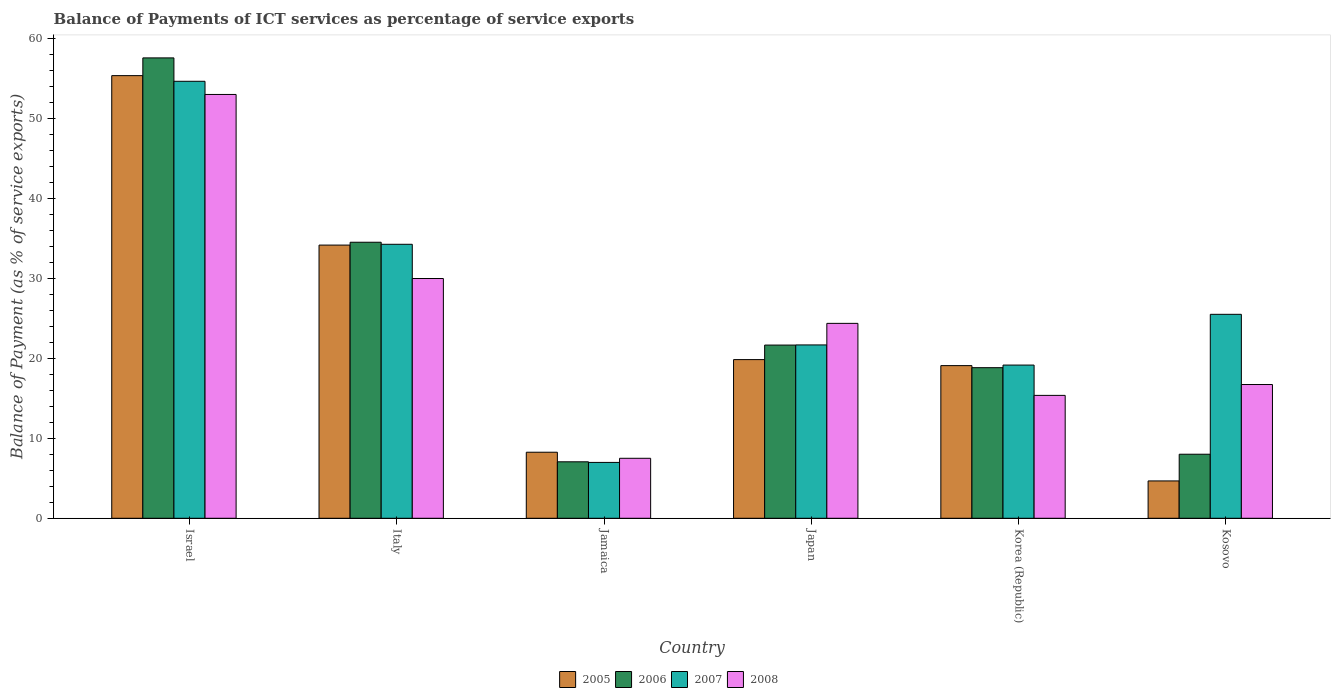How many different coloured bars are there?
Your response must be concise. 4. Are the number of bars on each tick of the X-axis equal?
Your response must be concise. Yes. How many bars are there on the 6th tick from the left?
Make the answer very short. 4. How many bars are there on the 3rd tick from the right?
Your response must be concise. 4. What is the label of the 1st group of bars from the left?
Ensure brevity in your answer.  Israel. In how many cases, is the number of bars for a given country not equal to the number of legend labels?
Ensure brevity in your answer.  0. What is the balance of payments of ICT services in 2008 in Jamaica?
Your answer should be very brief. 7.5. Across all countries, what is the maximum balance of payments of ICT services in 2006?
Make the answer very short. 57.59. Across all countries, what is the minimum balance of payments of ICT services in 2007?
Your answer should be compact. 6.99. In which country was the balance of payments of ICT services in 2007 minimum?
Provide a succinct answer. Jamaica. What is the total balance of payments of ICT services in 2006 in the graph?
Keep it short and to the point. 147.7. What is the difference between the balance of payments of ICT services in 2007 in Israel and that in Italy?
Provide a short and direct response. 20.39. What is the difference between the balance of payments of ICT services in 2006 in Japan and the balance of payments of ICT services in 2007 in Italy?
Ensure brevity in your answer.  -12.61. What is the average balance of payments of ICT services in 2006 per country?
Provide a succinct answer. 24.62. What is the difference between the balance of payments of ICT services of/in 2006 and balance of payments of ICT services of/in 2005 in Israel?
Provide a succinct answer. 2.22. What is the ratio of the balance of payments of ICT services in 2008 in Italy to that in Kosovo?
Ensure brevity in your answer.  1.79. Is the balance of payments of ICT services in 2006 in Italy less than that in Korea (Republic)?
Make the answer very short. No. Is the difference between the balance of payments of ICT services in 2006 in Israel and Korea (Republic) greater than the difference between the balance of payments of ICT services in 2005 in Israel and Korea (Republic)?
Your response must be concise. Yes. What is the difference between the highest and the second highest balance of payments of ICT services in 2006?
Offer a terse response. 23.06. What is the difference between the highest and the lowest balance of payments of ICT services in 2006?
Make the answer very short. 50.53. Is the sum of the balance of payments of ICT services in 2007 in Italy and Jamaica greater than the maximum balance of payments of ICT services in 2006 across all countries?
Ensure brevity in your answer.  No. What does the 4th bar from the left in Israel represents?
Provide a short and direct response. 2008. What does the 3rd bar from the right in Jamaica represents?
Keep it short and to the point. 2006. Is it the case that in every country, the sum of the balance of payments of ICT services in 2008 and balance of payments of ICT services in 2006 is greater than the balance of payments of ICT services in 2005?
Give a very brief answer. Yes. Are all the bars in the graph horizontal?
Make the answer very short. No. Are the values on the major ticks of Y-axis written in scientific E-notation?
Provide a succinct answer. No. Does the graph contain any zero values?
Keep it short and to the point. No. Where does the legend appear in the graph?
Offer a very short reply. Bottom center. How are the legend labels stacked?
Offer a terse response. Horizontal. What is the title of the graph?
Offer a terse response. Balance of Payments of ICT services as percentage of service exports. Does "2009" appear as one of the legend labels in the graph?
Ensure brevity in your answer.  No. What is the label or title of the Y-axis?
Your response must be concise. Balance of Payment (as % of service exports). What is the Balance of Payment (as % of service exports) of 2005 in Israel?
Offer a terse response. 55.37. What is the Balance of Payment (as % of service exports) of 2006 in Israel?
Provide a succinct answer. 57.59. What is the Balance of Payment (as % of service exports) of 2007 in Israel?
Your answer should be compact. 54.67. What is the Balance of Payment (as % of service exports) of 2008 in Israel?
Provide a short and direct response. 53.02. What is the Balance of Payment (as % of service exports) of 2005 in Italy?
Provide a succinct answer. 34.17. What is the Balance of Payment (as % of service exports) of 2006 in Italy?
Provide a short and direct response. 34.53. What is the Balance of Payment (as % of service exports) in 2007 in Italy?
Your answer should be very brief. 34.28. What is the Balance of Payment (as % of service exports) of 2008 in Italy?
Your answer should be compact. 29.99. What is the Balance of Payment (as % of service exports) in 2005 in Jamaica?
Your answer should be very brief. 8.26. What is the Balance of Payment (as % of service exports) in 2006 in Jamaica?
Offer a very short reply. 7.06. What is the Balance of Payment (as % of service exports) of 2007 in Jamaica?
Give a very brief answer. 6.99. What is the Balance of Payment (as % of service exports) in 2008 in Jamaica?
Keep it short and to the point. 7.5. What is the Balance of Payment (as % of service exports) of 2005 in Japan?
Your response must be concise. 19.85. What is the Balance of Payment (as % of service exports) in 2006 in Japan?
Keep it short and to the point. 21.67. What is the Balance of Payment (as % of service exports) of 2007 in Japan?
Offer a very short reply. 21.69. What is the Balance of Payment (as % of service exports) of 2008 in Japan?
Your response must be concise. 24.38. What is the Balance of Payment (as % of service exports) in 2005 in Korea (Republic)?
Your answer should be compact. 19.1. What is the Balance of Payment (as % of service exports) in 2006 in Korea (Republic)?
Make the answer very short. 18.84. What is the Balance of Payment (as % of service exports) of 2007 in Korea (Republic)?
Give a very brief answer. 19.16. What is the Balance of Payment (as % of service exports) in 2008 in Korea (Republic)?
Ensure brevity in your answer.  15.37. What is the Balance of Payment (as % of service exports) in 2005 in Kosovo?
Offer a very short reply. 4.67. What is the Balance of Payment (as % of service exports) in 2006 in Kosovo?
Provide a short and direct response. 8.01. What is the Balance of Payment (as % of service exports) in 2007 in Kosovo?
Your answer should be compact. 25.51. What is the Balance of Payment (as % of service exports) in 2008 in Kosovo?
Make the answer very short. 16.73. Across all countries, what is the maximum Balance of Payment (as % of service exports) of 2005?
Ensure brevity in your answer.  55.37. Across all countries, what is the maximum Balance of Payment (as % of service exports) of 2006?
Give a very brief answer. 57.59. Across all countries, what is the maximum Balance of Payment (as % of service exports) in 2007?
Provide a short and direct response. 54.67. Across all countries, what is the maximum Balance of Payment (as % of service exports) of 2008?
Ensure brevity in your answer.  53.02. Across all countries, what is the minimum Balance of Payment (as % of service exports) in 2005?
Ensure brevity in your answer.  4.67. Across all countries, what is the minimum Balance of Payment (as % of service exports) of 2006?
Your answer should be very brief. 7.06. Across all countries, what is the minimum Balance of Payment (as % of service exports) in 2007?
Offer a very short reply. 6.99. Across all countries, what is the minimum Balance of Payment (as % of service exports) of 2008?
Your answer should be very brief. 7.5. What is the total Balance of Payment (as % of service exports) of 2005 in the graph?
Your response must be concise. 141.43. What is the total Balance of Payment (as % of service exports) in 2006 in the graph?
Offer a very short reply. 147.7. What is the total Balance of Payment (as % of service exports) of 2007 in the graph?
Keep it short and to the point. 162.29. What is the total Balance of Payment (as % of service exports) of 2008 in the graph?
Offer a very short reply. 147. What is the difference between the Balance of Payment (as % of service exports) in 2005 in Israel and that in Italy?
Give a very brief answer. 21.2. What is the difference between the Balance of Payment (as % of service exports) of 2006 in Israel and that in Italy?
Make the answer very short. 23.06. What is the difference between the Balance of Payment (as % of service exports) of 2007 in Israel and that in Italy?
Keep it short and to the point. 20.39. What is the difference between the Balance of Payment (as % of service exports) in 2008 in Israel and that in Italy?
Keep it short and to the point. 23.02. What is the difference between the Balance of Payment (as % of service exports) of 2005 in Israel and that in Jamaica?
Offer a terse response. 47.11. What is the difference between the Balance of Payment (as % of service exports) of 2006 in Israel and that in Jamaica?
Offer a very short reply. 50.53. What is the difference between the Balance of Payment (as % of service exports) in 2007 in Israel and that in Jamaica?
Your answer should be very brief. 47.68. What is the difference between the Balance of Payment (as % of service exports) in 2008 in Israel and that in Jamaica?
Your answer should be very brief. 45.51. What is the difference between the Balance of Payment (as % of service exports) of 2005 in Israel and that in Japan?
Your answer should be compact. 35.52. What is the difference between the Balance of Payment (as % of service exports) in 2006 in Israel and that in Japan?
Your answer should be very brief. 35.93. What is the difference between the Balance of Payment (as % of service exports) of 2007 in Israel and that in Japan?
Give a very brief answer. 32.98. What is the difference between the Balance of Payment (as % of service exports) of 2008 in Israel and that in Japan?
Offer a terse response. 28.64. What is the difference between the Balance of Payment (as % of service exports) of 2005 in Israel and that in Korea (Republic)?
Your answer should be very brief. 36.28. What is the difference between the Balance of Payment (as % of service exports) of 2006 in Israel and that in Korea (Republic)?
Your response must be concise. 38.75. What is the difference between the Balance of Payment (as % of service exports) in 2007 in Israel and that in Korea (Republic)?
Ensure brevity in your answer.  35.5. What is the difference between the Balance of Payment (as % of service exports) of 2008 in Israel and that in Korea (Republic)?
Your answer should be compact. 37.64. What is the difference between the Balance of Payment (as % of service exports) in 2005 in Israel and that in Kosovo?
Offer a terse response. 50.7. What is the difference between the Balance of Payment (as % of service exports) of 2006 in Israel and that in Kosovo?
Make the answer very short. 49.58. What is the difference between the Balance of Payment (as % of service exports) in 2007 in Israel and that in Kosovo?
Provide a short and direct response. 29.15. What is the difference between the Balance of Payment (as % of service exports) of 2008 in Israel and that in Kosovo?
Offer a terse response. 36.29. What is the difference between the Balance of Payment (as % of service exports) in 2005 in Italy and that in Jamaica?
Offer a very short reply. 25.91. What is the difference between the Balance of Payment (as % of service exports) in 2006 in Italy and that in Jamaica?
Ensure brevity in your answer.  27.47. What is the difference between the Balance of Payment (as % of service exports) in 2007 in Italy and that in Jamaica?
Your response must be concise. 27.29. What is the difference between the Balance of Payment (as % of service exports) of 2008 in Italy and that in Jamaica?
Keep it short and to the point. 22.49. What is the difference between the Balance of Payment (as % of service exports) in 2005 in Italy and that in Japan?
Provide a short and direct response. 14.33. What is the difference between the Balance of Payment (as % of service exports) of 2006 in Italy and that in Japan?
Give a very brief answer. 12.87. What is the difference between the Balance of Payment (as % of service exports) of 2007 in Italy and that in Japan?
Make the answer very short. 12.59. What is the difference between the Balance of Payment (as % of service exports) in 2008 in Italy and that in Japan?
Offer a terse response. 5.61. What is the difference between the Balance of Payment (as % of service exports) in 2005 in Italy and that in Korea (Republic)?
Make the answer very short. 15.08. What is the difference between the Balance of Payment (as % of service exports) of 2006 in Italy and that in Korea (Republic)?
Your answer should be very brief. 15.69. What is the difference between the Balance of Payment (as % of service exports) of 2007 in Italy and that in Korea (Republic)?
Your answer should be compact. 15.11. What is the difference between the Balance of Payment (as % of service exports) in 2008 in Italy and that in Korea (Republic)?
Offer a terse response. 14.62. What is the difference between the Balance of Payment (as % of service exports) of 2005 in Italy and that in Kosovo?
Give a very brief answer. 29.5. What is the difference between the Balance of Payment (as % of service exports) of 2006 in Italy and that in Kosovo?
Your answer should be compact. 26.52. What is the difference between the Balance of Payment (as % of service exports) of 2007 in Italy and that in Kosovo?
Keep it short and to the point. 8.76. What is the difference between the Balance of Payment (as % of service exports) of 2008 in Italy and that in Kosovo?
Give a very brief answer. 13.26. What is the difference between the Balance of Payment (as % of service exports) in 2005 in Jamaica and that in Japan?
Provide a succinct answer. -11.59. What is the difference between the Balance of Payment (as % of service exports) of 2006 in Jamaica and that in Japan?
Your answer should be compact. -14.6. What is the difference between the Balance of Payment (as % of service exports) in 2007 in Jamaica and that in Japan?
Keep it short and to the point. -14.7. What is the difference between the Balance of Payment (as % of service exports) of 2008 in Jamaica and that in Japan?
Offer a very short reply. -16.88. What is the difference between the Balance of Payment (as % of service exports) in 2005 in Jamaica and that in Korea (Republic)?
Your response must be concise. -10.83. What is the difference between the Balance of Payment (as % of service exports) in 2006 in Jamaica and that in Korea (Republic)?
Keep it short and to the point. -11.78. What is the difference between the Balance of Payment (as % of service exports) in 2007 in Jamaica and that in Korea (Republic)?
Provide a succinct answer. -12.18. What is the difference between the Balance of Payment (as % of service exports) in 2008 in Jamaica and that in Korea (Republic)?
Give a very brief answer. -7.87. What is the difference between the Balance of Payment (as % of service exports) of 2005 in Jamaica and that in Kosovo?
Provide a short and direct response. 3.59. What is the difference between the Balance of Payment (as % of service exports) in 2006 in Jamaica and that in Kosovo?
Your answer should be very brief. -0.95. What is the difference between the Balance of Payment (as % of service exports) of 2007 in Jamaica and that in Kosovo?
Give a very brief answer. -18.53. What is the difference between the Balance of Payment (as % of service exports) in 2008 in Jamaica and that in Kosovo?
Ensure brevity in your answer.  -9.23. What is the difference between the Balance of Payment (as % of service exports) of 2005 in Japan and that in Korea (Republic)?
Offer a terse response. 0.75. What is the difference between the Balance of Payment (as % of service exports) in 2006 in Japan and that in Korea (Republic)?
Ensure brevity in your answer.  2.83. What is the difference between the Balance of Payment (as % of service exports) of 2007 in Japan and that in Korea (Republic)?
Ensure brevity in your answer.  2.52. What is the difference between the Balance of Payment (as % of service exports) in 2008 in Japan and that in Korea (Republic)?
Make the answer very short. 9.01. What is the difference between the Balance of Payment (as % of service exports) of 2005 in Japan and that in Kosovo?
Offer a terse response. 15.18. What is the difference between the Balance of Payment (as % of service exports) in 2006 in Japan and that in Kosovo?
Provide a short and direct response. 13.66. What is the difference between the Balance of Payment (as % of service exports) in 2007 in Japan and that in Kosovo?
Provide a short and direct response. -3.83. What is the difference between the Balance of Payment (as % of service exports) in 2008 in Japan and that in Kosovo?
Offer a terse response. 7.65. What is the difference between the Balance of Payment (as % of service exports) of 2005 in Korea (Republic) and that in Kosovo?
Ensure brevity in your answer.  14.43. What is the difference between the Balance of Payment (as % of service exports) of 2006 in Korea (Republic) and that in Kosovo?
Your answer should be compact. 10.83. What is the difference between the Balance of Payment (as % of service exports) of 2007 in Korea (Republic) and that in Kosovo?
Offer a terse response. -6.35. What is the difference between the Balance of Payment (as % of service exports) in 2008 in Korea (Republic) and that in Kosovo?
Keep it short and to the point. -1.36. What is the difference between the Balance of Payment (as % of service exports) in 2005 in Israel and the Balance of Payment (as % of service exports) in 2006 in Italy?
Provide a succinct answer. 20.84. What is the difference between the Balance of Payment (as % of service exports) in 2005 in Israel and the Balance of Payment (as % of service exports) in 2007 in Italy?
Your answer should be compact. 21.1. What is the difference between the Balance of Payment (as % of service exports) of 2005 in Israel and the Balance of Payment (as % of service exports) of 2008 in Italy?
Offer a very short reply. 25.38. What is the difference between the Balance of Payment (as % of service exports) of 2006 in Israel and the Balance of Payment (as % of service exports) of 2007 in Italy?
Provide a short and direct response. 23.32. What is the difference between the Balance of Payment (as % of service exports) in 2006 in Israel and the Balance of Payment (as % of service exports) in 2008 in Italy?
Your answer should be very brief. 27.6. What is the difference between the Balance of Payment (as % of service exports) in 2007 in Israel and the Balance of Payment (as % of service exports) in 2008 in Italy?
Provide a short and direct response. 24.67. What is the difference between the Balance of Payment (as % of service exports) in 2005 in Israel and the Balance of Payment (as % of service exports) in 2006 in Jamaica?
Provide a short and direct response. 48.31. What is the difference between the Balance of Payment (as % of service exports) of 2005 in Israel and the Balance of Payment (as % of service exports) of 2007 in Jamaica?
Offer a terse response. 48.39. What is the difference between the Balance of Payment (as % of service exports) of 2005 in Israel and the Balance of Payment (as % of service exports) of 2008 in Jamaica?
Ensure brevity in your answer.  47.87. What is the difference between the Balance of Payment (as % of service exports) of 2006 in Israel and the Balance of Payment (as % of service exports) of 2007 in Jamaica?
Keep it short and to the point. 50.61. What is the difference between the Balance of Payment (as % of service exports) in 2006 in Israel and the Balance of Payment (as % of service exports) in 2008 in Jamaica?
Keep it short and to the point. 50.09. What is the difference between the Balance of Payment (as % of service exports) in 2007 in Israel and the Balance of Payment (as % of service exports) in 2008 in Jamaica?
Your answer should be very brief. 47.16. What is the difference between the Balance of Payment (as % of service exports) in 2005 in Israel and the Balance of Payment (as % of service exports) in 2006 in Japan?
Give a very brief answer. 33.71. What is the difference between the Balance of Payment (as % of service exports) in 2005 in Israel and the Balance of Payment (as % of service exports) in 2007 in Japan?
Provide a short and direct response. 33.69. What is the difference between the Balance of Payment (as % of service exports) of 2005 in Israel and the Balance of Payment (as % of service exports) of 2008 in Japan?
Make the answer very short. 30.99. What is the difference between the Balance of Payment (as % of service exports) of 2006 in Israel and the Balance of Payment (as % of service exports) of 2007 in Japan?
Offer a very short reply. 35.91. What is the difference between the Balance of Payment (as % of service exports) of 2006 in Israel and the Balance of Payment (as % of service exports) of 2008 in Japan?
Keep it short and to the point. 33.21. What is the difference between the Balance of Payment (as % of service exports) of 2007 in Israel and the Balance of Payment (as % of service exports) of 2008 in Japan?
Keep it short and to the point. 30.28. What is the difference between the Balance of Payment (as % of service exports) of 2005 in Israel and the Balance of Payment (as % of service exports) of 2006 in Korea (Republic)?
Ensure brevity in your answer.  36.53. What is the difference between the Balance of Payment (as % of service exports) of 2005 in Israel and the Balance of Payment (as % of service exports) of 2007 in Korea (Republic)?
Provide a short and direct response. 36.21. What is the difference between the Balance of Payment (as % of service exports) in 2005 in Israel and the Balance of Payment (as % of service exports) in 2008 in Korea (Republic)?
Give a very brief answer. 40. What is the difference between the Balance of Payment (as % of service exports) in 2006 in Israel and the Balance of Payment (as % of service exports) in 2007 in Korea (Republic)?
Ensure brevity in your answer.  38.43. What is the difference between the Balance of Payment (as % of service exports) in 2006 in Israel and the Balance of Payment (as % of service exports) in 2008 in Korea (Republic)?
Keep it short and to the point. 42.22. What is the difference between the Balance of Payment (as % of service exports) of 2007 in Israel and the Balance of Payment (as % of service exports) of 2008 in Korea (Republic)?
Provide a succinct answer. 39.29. What is the difference between the Balance of Payment (as % of service exports) in 2005 in Israel and the Balance of Payment (as % of service exports) in 2006 in Kosovo?
Your response must be concise. 47.36. What is the difference between the Balance of Payment (as % of service exports) of 2005 in Israel and the Balance of Payment (as % of service exports) of 2007 in Kosovo?
Your response must be concise. 29.86. What is the difference between the Balance of Payment (as % of service exports) of 2005 in Israel and the Balance of Payment (as % of service exports) of 2008 in Kosovo?
Make the answer very short. 38.64. What is the difference between the Balance of Payment (as % of service exports) in 2006 in Israel and the Balance of Payment (as % of service exports) in 2007 in Kosovo?
Your answer should be compact. 32.08. What is the difference between the Balance of Payment (as % of service exports) of 2006 in Israel and the Balance of Payment (as % of service exports) of 2008 in Kosovo?
Keep it short and to the point. 40.86. What is the difference between the Balance of Payment (as % of service exports) of 2007 in Israel and the Balance of Payment (as % of service exports) of 2008 in Kosovo?
Offer a very short reply. 37.94. What is the difference between the Balance of Payment (as % of service exports) in 2005 in Italy and the Balance of Payment (as % of service exports) in 2006 in Jamaica?
Your answer should be compact. 27.11. What is the difference between the Balance of Payment (as % of service exports) of 2005 in Italy and the Balance of Payment (as % of service exports) of 2007 in Jamaica?
Provide a short and direct response. 27.19. What is the difference between the Balance of Payment (as % of service exports) in 2005 in Italy and the Balance of Payment (as % of service exports) in 2008 in Jamaica?
Offer a terse response. 26.67. What is the difference between the Balance of Payment (as % of service exports) of 2006 in Italy and the Balance of Payment (as % of service exports) of 2007 in Jamaica?
Ensure brevity in your answer.  27.54. What is the difference between the Balance of Payment (as % of service exports) of 2006 in Italy and the Balance of Payment (as % of service exports) of 2008 in Jamaica?
Ensure brevity in your answer.  27.03. What is the difference between the Balance of Payment (as % of service exports) of 2007 in Italy and the Balance of Payment (as % of service exports) of 2008 in Jamaica?
Give a very brief answer. 26.77. What is the difference between the Balance of Payment (as % of service exports) of 2005 in Italy and the Balance of Payment (as % of service exports) of 2006 in Japan?
Ensure brevity in your answer.  12.51. What is the difference between the Balance of Payment (as % of service exports) in 2005 in Italy and the Balance of Payment (as % of service exports) in 2007 in Japan?
Your answer should be very brief. 12.49. What is the difference between the Balance of Payment (as % of service exports) of 2005 in Italy and the Balance of Payment (as % of service exports) of 2008 in Japan?
Your answer should be very brief. 9.79. What is the difference between the Balance of Payment (as % of service exports) of 2006 in Italy and the Balance of Payment (as % of service exports) of 2007 in Japan?
Offer a terse response. 12.85. What is the difference between the Balance of Payment (as % of service exports) of 2006 in Italy and the Balance of Payment (as % of service exports) of 2008 in Japan?
Give a very brief answer. 10.15. What is the difference between the Balance of Payment (as % of service exports) of 2007 in Italy and the Balance of Payment (as % of service exports) of 2008 in Japan?
Provide a short and direct response. 9.89. What is the difference between the Balance of Payment (as % of service exports) in 2005 in Italy and the Balance of Payment (as % of service exports) in 2006 in Korea (Republic)?
Give a very brief answer. 15.34. What is the difference between the Balance of Payment (as % of service exports) of 2005 in Italy and the Balance of Payment (as % of service exports) of 2007 in Korea (Republic)?
Ensure brevity in your answer.  15.01. What is the difference between the Balance of Payment (as % of service exports) in 2005 in Italy and the Balance of Payment (as % of service exports) in 2008 in Korea (Republic)?
Your response must be concise. 18.8. What is the difference between the Balance of Payment (as % of service exports) in 2006 in Italy and the Balance of Payment (as % of service exports) in 2007 in Korea (Republic)?
Provide a succinct answer. 15.37. What is the difference between the Balance of Payment (as % of service exports) of 2006 in Italy and the Balance of Payment (as % of service exports) of 2008 in Korea (Republic)?
Make the answer very short. 19.16. What is the difference between the Balance of Payment (as % of service exports) in 2007 in Italy and the Balance of Payment (as % of service exports) in 2008 in Korea (Republic)?
Ensure brevity in your answer.  18.9. What is the difference between the Balance of Payment (as % of service exports) of 2005 in Italy and the Balance of Payment (as % of service exports) of 2006 in Kosovo?
Your answer should be very brief. 26.16. What is the difference between the Balance of Payment (as % of service exports) of 2005 in Italy and the Balance of Payment (as % of service exports) of 2007 in Kosovo?
Make the answer very short. 8.66. What is the difference between the Balance of Payment (as % of service exports) of 2005 in Italy and the Balance of Payment (as % of service exports) of 2008 in Kosovo?
Offer a terse response. 17.44. What is the difference between the Balance of Payment (as % of service exports) in 2006 in Italy and the Balance of Payment (as % of service exports) in 2007 in Kosovo?
Make the answer very short. 9.02. What is the difference between the Balance of Payment (as % of service exports) of 2006 in Italy and the Balance of Payment (as % of service exports) of 2008 in Kosovo?
Your answer should be very brief. 17.8. What is the difference between the Balance of Payment (as % of service exports) of 2007 in Italy and the Balance of Payment (as % of service exports) of 2008 in Kosovo?
Provide a short and direct response. 17.54. What is the difference between the Balance of Payment (as % of service exports) of 2005 in Jamaica and the Balance of Payment (as % of service exports) of 2006 in Japan?
Provide a short and direct response. -13.4. What is the difference between the Balance of Payment (as % of service exports) in 2005 in Jamaica and the Balance of Payment (as % of service exports) in 2007 in Japan?
Ensure brevity in your answer.  -13.42. What is the difference between the Balance of Payment (as % of service exports) in 2005 in Jamaica and the Balance of Payment (as % of service exports) in 2008 in Japan?
Your answer should be very brief. -16.12. What is the difference between the Balance of Payment (as % of service exports) of 2006 in Jamaica and the Balance of Payment (as % of service exports) of 2007 in Japan?
Your response must be concise. -14.62. What is the difference between the Balance of Payment (as % of service exports) of 2006 in Jamaica and the Balance of Payment (as % of service exports) of 2008 in Japan?
Offer a terse response. -17.32. What is the difference between the Balance of Payment (as % of service exports) of 2007 in Jamaica and the Balance of Payment (as % of service exports) of 2008 in Japan?
Give a very brief answer. -17.39. What is the difference between the Balance of Payment (as % of service exports) of 2005 in Jamaica and the Balance of Payment (as % of service exports) of 2006 in Korea (Republic)?
Your answer should be very brief. -10.58. What is the difference between the Balance of Payment (as % of service exports) of 2005 in Jamaica and the Balance of Payment (as % of service exports) of 2007 in Korea (Republic)?
Provide a short and direct response. -10.9. What is the difference between the Balance of Payment (as % of service exports) of 2005 in Jamaica and the Balance of Payment (as % of service exports) of 2008 in Korea (Republic)?
Offer a very short reply. -7.11. What is the difference between the Balance of Payment (as % of service exports) of 2006 in Jamaica and the Balance of Payment (as % of service exports) of 2007 in Korea (Republic)?
Your answer should be compact. -12.1. What is the difference between the Balance of Payment (as % of service exports) in 2006 in Jamaica and the Balance of Payment (as % of service exports) in 2008 in Korea (Republic)?
Your response must be concise. -8.31. What is the difference between the Balance of Payment (as % of service exports) in 2007 in Jamaica and the Balance of Payment (as % of service exports) in 2008 in Korea (Republic)?
Make the answer very short. -8.39. What is the difference between the Balance of Payment (as % of service exports) of 2005 in Jamaica and the Balance of Payment (as % of service exports) of 2006 in Kosovo?
Offer a very short reply. 0.25. What is the difference between the Balance of Payment (as % of service exports) in 2005 in Jamaica and the Balance of Payment (as % of service exports) in 2007 in Kosovo?
Provide a succinct answer. -17.25. What is the difference between the Balance of Payment (as % of service exports) in 2005 in Jamaica and the Balance of Payment (as % of service exports) in 2008 in Kosovo?
Give a very brief answer. -8.47. What is the difference between the Balance of Payment (as % of service exports) of 2006 in Jamaica and the Balance of Payment (as % of service exports) of 2007 in Kosovo?
Your response must be concise. -18.45. What is the difference between the Balance of Payment (as % of service exports) of 2006 in Jamaica and the Balance of Payment (as % of service exports) of 2008 in Kosovo?
Offer a very short reply. -9.67. What is the difference between the Balance of Payment (as % of service exports) in 2007 in Jamaica and the Balance of Payment (as % of service exports) in 2008 in Kosovo?
Offer a very short reply. -9.74. What is the difference between the Balance of Payment (as % of service exports) in 2005 in Japan and the Balance of Payment (as % of service exports) in 2006 in Korea (Republic)?
Your response must be concise. 1.01. What is the difference between the Balance of Payment (as % of service exports) in 2005 in Japan and the Balance of Payment (as % of service exports) in 2007 in Korea (Republic)?
Keep it short and to the point. 0.68. What is the difference between the Balance of Payment (as % of service exports) in 2005 in Japan and the Balance of Payment (as % of service exports) in 2008 in Korea (Republic)?
Make the answer very short. 4.48. What is the difference between the Balance of Payment (as % of service exports) of 2006 in Japan and the Balance of Payment (as % of service exports) of 2007 in Korea (Republic)?
Offer a very short reply. 2.5. What is the difference between the Balance of Payment (as % of service exports) in 2006 in Japan and the Balance of Payment (as % of service exports) in 2008 in Korea (Republic)?
Your answer should be compact. 6.29. What is the difference between the Balance of Payment (as % of service exports) of 2007 in Japan and the Balance of Payment (as % of service exports) of 2008 in Korea (Republic)?
Your response must be concise. 6.31. What is the difference between the Balance of Payment (as % of service exports) in 2005 in Japan and the Balance of Payment (as % of service exports) in 2006 in Kosovo?
Offer a terse response. 11.84. What is the difference between the Balance of Payment (as % of service exports) of 2005 in Japan and the Balance of Payment (as % of service exports) of 2007 in Kosovo?
Your response must be concise. -5.67. What is the difference between the Balance of Payment (as % of service exports) in 2005 in Japan and the Balance of Payment (as % of service exports) in 2008 in Kosovo?
Your answer should be compact. 3.12. What is the difference between the Balance of Payment (as % of service exports) in 2006 in Japan and the Balance of Payment (as % of service exports) in 2007 in Kosovo?
Provide a short and direct response. -3.85. What is the difference between the Balance of Payment (as % of service exports) of 2006 in Japan and the Balance of Payment (as % of service exports) of 2008 in Kosovo?
Keep it short and to the point. 4.93. What is the difference between the Balance of Payment (as % of service exports) of 2007 in Japan and the Balance of Payment (as % of service exports) of 2008 in Kosovo?
Make the answer very short. 4.95. What is the difference between the Balance of Payment (as % of service exports) of 2005 in Korea (Republic) and the Balance of Payment (as % of service exports) of 2006 in Kosovo?
Make the answer very short. 11.09. What is the difference between the Balance of Payment (as % of service exports) in 2005 in Korea (Republic) and the Balance of Payment (as % of service exports) in 2007 in Kosovo?
Provide a short and direct response. -6.42. What is the difference between the Balance of Payment (as % of service exports) of 2005 in Korea (Republic) and the Balance of Payment (as % of service exports) of 2008 in Kosovo?
Make the answer very short. 2.37. What is the difference between the Balance of Payment (as % of service exports) of 2006 in Korea (Republic) and the Balance of Payment (as % of service exports) of 2007 in Kosovo?
Offer a terse response. -6.68. What is the difference between the Balance of Payment (as % of service exports) of 2006 in Korea (Republic) and the Balance of Payment (as % of service exports) of 2008 in Kosovo?
Give a very brief answer. 2.11. What is the difference between the Balance of Payment (as % of service exports) in 2007 in Korea (Republic) and the Balance of Payment (as % of service exports) in 2008 in Kosovo?
Provide a succinct answer. 2.43. What is the average Balance of Payment (as % of service exports) in 2005 per country?
Provide a short and direct response. 23.57. What is the average Balance of Payment (as % of service exports) of 2006 per country?
Your response must be concise. 24.62. What is the average Balance of Payment (as % of service exports) in 2007 per country?
Provide a short and direct response. 27.05. What is the average Balance of Payment (as % of service exports) in 2008 per country?
Keep it short and to the point. 24.5. What is the difference between the Balance of Payment (as % of service exports) of 2005 and Balance of Payment (as % of service exports) of 2006 in Israel?
Give a very brief answer. -2.22. What is the difference between the Balance of Payment (as % of service exports) of 2005 and Balance of Payment (as % of service exports) of 2007 in Israel?
Your answer should be compact. 0.71. What is the difference between the Balance of Payment (as % of service exports) of 2005 and Balance of Payment (as % of service exports) of 2008 in Israel?
Give a very brief answer. 2.36. What is the difference between the Balance of Payment (as % of service exports) in 2006 and Balance of Payment (as % of service exports) in 2007 in Israel?
Give a very brief answer. 2.93. What is the difference between the Balance of Payment (as % of service exports) of 2006 and Balance of Payment (as % of service exports) of 2008 in Israel?
Offer a very short reply. 4.57. What is the difference between the Balance of Payment (as % of service exports) of 2007 and Balance of Payment (as % of service exports) of 2008 in Israel?
Make the answer very short. 1.65. What is the difference between the Balance of Payment (as % of service exports) of 2005 and Balance of Payment (as % of service exports) of 2006 in Italy?
Your answer should be very brief. -0.36. What is the difference between the Balance of Payment (as % of service exports) in 2005 and Balance of Payment (as % of service exports) in 2007 in Italy?
Ensure brevity in your answer.  -0.1. What is the difference between the Balance of Payment (as % of service exports) of 2005 and Balance of Payment (as % of service exports) of 2008 in Italy?
Make the answer very short. 4.18. What is the difference between the Balance of Payment (as % of service exports) of 2006 and Balance of Payment (as % of service exports) of 2007 in Italy?
Your answer should be compact. 0.26. What is the difference between the Balance of Payment (as % of service exports) in 2006 and Balance of Payment (as % of service exports) in 2008 in Italy?
Your answer should be compact. 4.54. What is the difference between the Balance of Payment (as % of service exports) of 2007 and Balance of Payment (as % of service exports) of 2008 in Italy?
Provide a short and direct response. 4.28. What is the difference between the Balance of Payment (as % of service exports) of 2005 and Balance of Payment (as % of service exports) of 2006 in Jamaica?
Make the answer very short. 1.2. What is the difference between the Balance of Payment (as % of service exports) in 2005 and Balance of Payment (as % of service exports) in 2007 in Jamaica?
Make the answer very short. 1.28. What is the difference between the Balance of Payment (as % of service exports) in 2005 and Balance of Payment (as % of service exports) in 2008 in Jamaica?
Provide a succinct answer. 0.76. What is the difference between the Balance of Payment (as % of service exports) of 2006 and Balance of Payment (as % of service exports) of 2007 in Jamaica?
Ensure brevity in your answer.  0.08. What is the difference between the Balance of Payment (as % of service exports) of 2006 and Balance of Payment (as % of service exports) of 2008 in Jamaica?
Ensure brevity in your answer.  -0.44. What is the difference between the Balance of Payment (as % of service exports) in 2007 and Balance of Payment (as % of service exports) in 2008 in Jamaica?
Keep it short and to the point. -0.52. What is the difference between the Balance of Payment (as % of service exports) in 2005 and Balance of Payment (as % of service exports) in 2006 in Japan?
Offer a terse response. -1.82. What is the difference between the Balance of Payment (as % of service exports) in 2005 and Balance of Payment (as % of service exports) in 2007 in Japan?
Ensure brevity in your answer.  -1.84. What is the difference between the Balance of Payment (as % of service exports) of 2005 and Balance of Payment (as % of service exports) of 2008 in Japan?
Provide a short and direct response. -4.53. What is the difference between the Balance of Payment (as % of service exports) in 2006 and Balance of Payment (as % of service exports) in 2007 in Japan?
Provide a succinct answer. -0.02. What is the difference between the Balance of Payment (as % of service exports) of 2006 and Balance of Payment (as % of service exports) of 2008 in Japan?
Your response must be concise. -2.72. What is the difference between the Balance of Payment (as % of service exports) of 2007 and Balance of Payment (as % of service exports) of 2008 in Japan?
Ensure brevity in your answer.  -2.7. What is the difference between the Balance of Payment (as % of service exports) of 2005 and Balance of Payment (as % of service exports) of 2006 in Korea (Republic)?
Keep it short and to the point. 0.26. What is the difference between the Balance of Payment (as % of service exports) of 2005 and Balance of Payment (as % of service exports) of 2007 in Korea (Republic)?
Keep it short and to the point. -0.07. What is the difference between the Balance of Payment (as % of service exports) of 2005 and Balance of Payment (as % of service exports) of 2008 in Korea (Republic)?
Your answer should be very brief. 3.72. What is the difference between the Balance of Payment (as % of service exports) in 2006 and Balance of Payment (as % of service exports) in 2007 in Korea (Republic)?
Your answer should be very brief. -0.33. What is the difference between the Balance of Payment (as % of service exports) of 2006 and Balance of Payment (as % of service exports) of 2008 in Korea (Republic)?
Offer a terse response. 3.46. What is the difference between the Balance of Payment (as % of service exports) of 2007 and Balance of Payment (as % of service exports) of 2008 in Korea (Republic)?
Ensure brevity in your answer.  3.79. What is the difference between the Balance of Payment (as % of service exports) of 2005 and Balance of Payment (as % of service exports) of 2006 in Kosovo?
Your answer should be compact. -3.34. What is the difference between the Balance of Payment (as % of service exports) in 2005 and Balance of Payment (as % of service exports) in 2007 in Kosovo?
Your answer should be very brief. -20.84. What is the difference between the Balance of Payment (as % of service exports) in 2005 and Balance of Payment (as % of service exports) in 2008 in Kosovo?
Keep it short and to the point. -12.06. What is the difference between the Balance of Payment (as % of service exports) of 2006 and Balance of Payment (as % of service exports) of 2007 in Kosovo?
Ensure brevity in your answer.  -17.5. What is the difference between the Balance of Payment (as % of service exports) in 2006 and Balance of Payment (as % of service exports) in 2008 in Kosovo?
Ensure brevity in your answer.  -8.72. What is the difference between the Balance of Payment (as % of service exports) of 2007 and Balance of Payment (as % of service exports) of 2008 in Kosovo?
Offer a terse response. 8.78. What is the ratio of the Balance of Payment (as % of service exports) in 2005 in Israel to that in Italy?
Keep it short and to the point. 1.62. What is the ratio of the Balance of Payment (as % of service exports) in 2006 in Israel to that in Italy?
Make the answer very short. 1.67. What is the ratio of the Balance of Payment (as % of service exports) in 2007 in Israel to that in Italy?
Make the answer very short. 1.59. What is the ratio of the Balance of Payment (as % of service exports) of 2008 in Israel to that in Italy?
Ensure brevity in your answer.  1.77. What is the ratio of the Balance of Payment (as % of service exports) of 2005 in Israel to that in Jamaica?
Provide a succinct answer. 6.7. What is the ratio of the Balance of Payment (as % of service exports) in 2006 in Israel to that in Jamaica?
Keep it short and to the point. 8.15. What is the ratio of the Balance of Payment (as % of service exports) of 2007 in Israel to that in Jamaica?
Provide a short and direct response. 7.82. What is the ratio of the Balance of Payment (as % of service exports) of 2008 in Israel to that in Jamaica?
Your answer should be very brief. 7.07. What is the ratio of the Balance of Payment (as % of service exports) in 2005 in Israel to that in Japan?
Offer a very short reply. 2.79. What is the ratio of the Balance of Payment (as % of service exports) of 2006 in Israel to that in Japan?
Your answer should be very brief. 2.66. What is the ratio of the Balance of Payment (as % of service exports) of 2007 in Israel to that in Japan?
Keep it short and to the point. 2.52. What is the ratio of the Balance of Payment (as % of service exports) in 2008 in Israel to that in Japan?
Give a very brief answer. 2.17. What is the ratio of the Balance of Payment (as % of service exports) of 2005 in Israel to that in Korea (Republic)?
Provide a short and direct response. 2.9. What is the ratio of the Balance of Payment (as % of service exports) of 2006 in Israel to that in Korea (Republic)?
Your response must be concise. 3.06. What is the ratio of the Balance of Payment (as % of service exports) in 2007 in Israel to that in Korea (Republic)?
Offer a very short reply. 2.85. What is the ratio of the Balance of Payment (as % of service exports) in 2008 in Israel to that in Korea (Republic)?
Your answer should be very brief. 3.45. What is the ratio of the Balance of Payment (as % of service exports) in 2005 in Israel to that in Kosovo?
Your answer should be very brief. 11.85. What is the ratio of the Balance of Payment (as % of service exports) in 2006 in Israel to that in Kosovo?
Ensure brevity in your answer.  7.19. What is the ratio of the Balance of Payment (as % of service exports) in 2007 in Israel to that in Kosovo?
Give a very brief answer. 2.14. What is the ratio of the Balance of Payment (as % of service exports) of 2008 in Israel to that in Kosovo?
Ensure brevity in your answer.  3.17. What is the ratio of the Balance of Payment (as % of service exports) in 2005 in Italy to that in Jamaica?
Your response must be concise. 4.14. What is the ratio of the Balance of Payment (as % of service exports) in 2006 in Italy to that in Jamaica?
Your response must be concise. 4.89. What is the ratio of the Balance of Payment (as % of service exports) in 2007 in Italy to that in Jamaica?
Make the answer very short. 4.91. What is the ratio of the Balance of Payment (as % of service exports) of 2008 in Italy to that in Jamaica?
Provide a succinct answer. 4. What is the ratio of the Balance of Payment (as % of service exports) of 2005 in Italy to that in Japan?
Ensure brevity in your answer.  1.72. What is the ratio of the Balance of Payment (as % of service exports) in 2006 in Italy to that in Japan?
Ensure brevity in your answer.  1.59. What is the ratio of the Balance of Payment (as % of service exports) of 2007 in Italy to that in Japan?
Offer a terse response. 1.58. What is the ratio of the Balance of Payment (as % of service exports) in 2008 in Italy to that in Japan?
Your answer should be very brief. 1.23. What is the ratio of the Balance of Payment (as % of service exports) of 2005 in Italy to that in Korea (Republic)?
Ensure brevity in your answer.  1.79. What is the ratio of the Balance of Payment (as % of service exports) in 2006 in Italy to that in Korea (Republic)?
Give a very brief answer. 1.83. What is the ratio of the Balance of Payment (as % of service exports) in 2007 in Italy to that in Korea (Republic)?
Offer a very short reply. 1.79. What is the ratio of the Balance of Payment (as % of service exports) in 2008 in Italy to that in Korea (Republic)?
Your answer should be very brief. 1.95. What is the ratio of the Balance of Payment (as % of service exports) of 2005 in Italy to that in Kosovo?
Ensure brevity in your answer.  7.32. What is the ratio of the Balance of Payment (as % of service exports) of 2006 in Italy to that in Kosovo?
Offer a very short reply. 4.31. What is the ratio of the Balance of Payment (as % of service exports) in 2007 in Italy to that in Kosovo?
Your answer should be very brief. 1.34. What is the ratio of the Balance of Payment (as % of service exports) of 2008 in Italy to that in Kosovo?
Make the answer very short. 1.79. What is the ratio of the Balance of Payment (as % of service exports) of 2005 in Jamaica to that in Japan?
Make the answer very short. 0.42. What is the ratio of the Balance of Payment (as % of service exports) in 2006 in Jamaica to that in Japan?
Offer a very short reply. 0.33. What is the ratio of the Balance of Payment (as % of service exports) in 2007 in Jamaica to that in Japan?
Your answer should be compact. 0.32. What is the ratio of the Balance of Payment (as % of service exports) of 2008 in Jamaica to that in Japan?
Make the answer very short. 0.31. What is the ratio of the Balance of Payment (as % of service exports) of 2005 in Jamaica to that in Korea (Republic)?
Give a very brief answer. 0.43. What is the ratio of the Balance of Payment (as % of service exports) in 2006 in Jamaica to that in Korea (Republic)?
Keep it short and to the point. 0.37. What is the ratio of the Balance of Payment (as % of service exports) in 2007 in Jamaica to that in Korea (Republic)?
Provide a succinct answer. 0.36. What is the ratio of the Balance of Payment (as % of service exports) in 2008 in Jamaica to that in Korea (Republic)?
Provide a short and direct response. 0.49. What is the ratio of the Balance of Payment (as % of service exports) of 2005 in Jamaica to that in Kosovo?
Your answer should be compact. 1.77. What is the ratio of the Balance of Payment (as % of service exports) in 2006 in Jamaica to that in Kosovo?
Offer a very short reply. 0.88. What is the ratio of the Balance of Payment (as % of service exports) of 2007 in Jamaica to that in Kosovo?
Offer a terse response. 0.27. What is the ratio of the Balance of Payment (as % of service exports) in 2008 in Jamaica to that in Kosovo?
Offer a very short reply. 0.45. What is the ratio of the Balance of Payment (as % of service exports) of 2005 in Japan to that in Korea (Republic)?
Your answer should be very brief. 1.04. What is the ratio of the Balance of Payment (as % of service exports) in 2006 in Japan to that in Korea (Republic)?
Offer a terse response. 1.15. What is the ratio of the Balance of Payment (as % of service exports) in 2007 in Japan to that in Korea (Republic)?
Offer a terse response. 1.13. What is the ratio of the Balance of Payment (as % of service exports) in 2008 in Japan to that in Korea (Republic)?
Your answer should be very brief. 1.59. What is the ratio of the Balance of Payment (as % of service exports) of 2005 in Japan to that in Kosovo?
Ensure brevity in your answer.  4.25. What is the ratio of the Balance of Payment (as % of service exports) in 2006 in Japan to that in Kosovo?
Your answer should be very brief. 2.7. What is the ratio of the Balance of Payment (as % of service exports) of 2007 in Japan to that in Kosovo?
Offer a terse response. 0.85. What is the ratio of the Balance of Payment (as % of service exports) in 2008 in Japan to that in Kosovo?
Offer a very short reply. 1.46. What is the ratio of the Balance of Payment (as % of service exports) in 2005 in Korea (Republic) to that in Kosovo?
Offer a very short reply. 4.09. What is the ratio of the Balance of Payment (as % of service exports) of 2006 in Korea (Republic) to that in Kosovo?
Provide a short and direct response. 2.35. What is the ratio of the Balance of Payment (as % of service exports) in 2007 in Korea (Republic) to that in Kosovo?
Give a very brief answer. 0.75. What is the ratio of the Balance of Payment (as % of service exports) in 2008 in Korea (Republic) to that in Kosovo?
Offer a terse response. 0.92. What is the difference between the highest and the second highest Balance of Payment (as % of service exports) of 2005?
Keep it short and to the point. 21.2. What is the difference between the highest and the second highest Balance of Payment (as % of service exports) in 2006?
Your response must be concise. 23.06. What is the difference between the highest and the second highest Balance of Payment (as % of service exports) of 2007?
Provide a short and direct response. 20.39. What is the difference between the highest and the second highest Balance of Payment (as % of service exports) of 2008?
Your answer should be compact. 23.02. What is the difference between the highest and the lowest Balance of Payment (as % of service exports) of 2005?
Ensure brevity in your answer.  50.7. What is the difference between the highest and the lowest Balance of Payment (as % of service exports) in 2006?
Your answer should be compact. 50.53. What is the difference between the highest and the lowest Balance of Payment (as % of service exports) in 2007?
Offer a very short reply. 47.68. What is the difference between the highest and the lowest Balance of Payment (as % of service exports) in 2008?
Offer a very short reply. 45.51. 